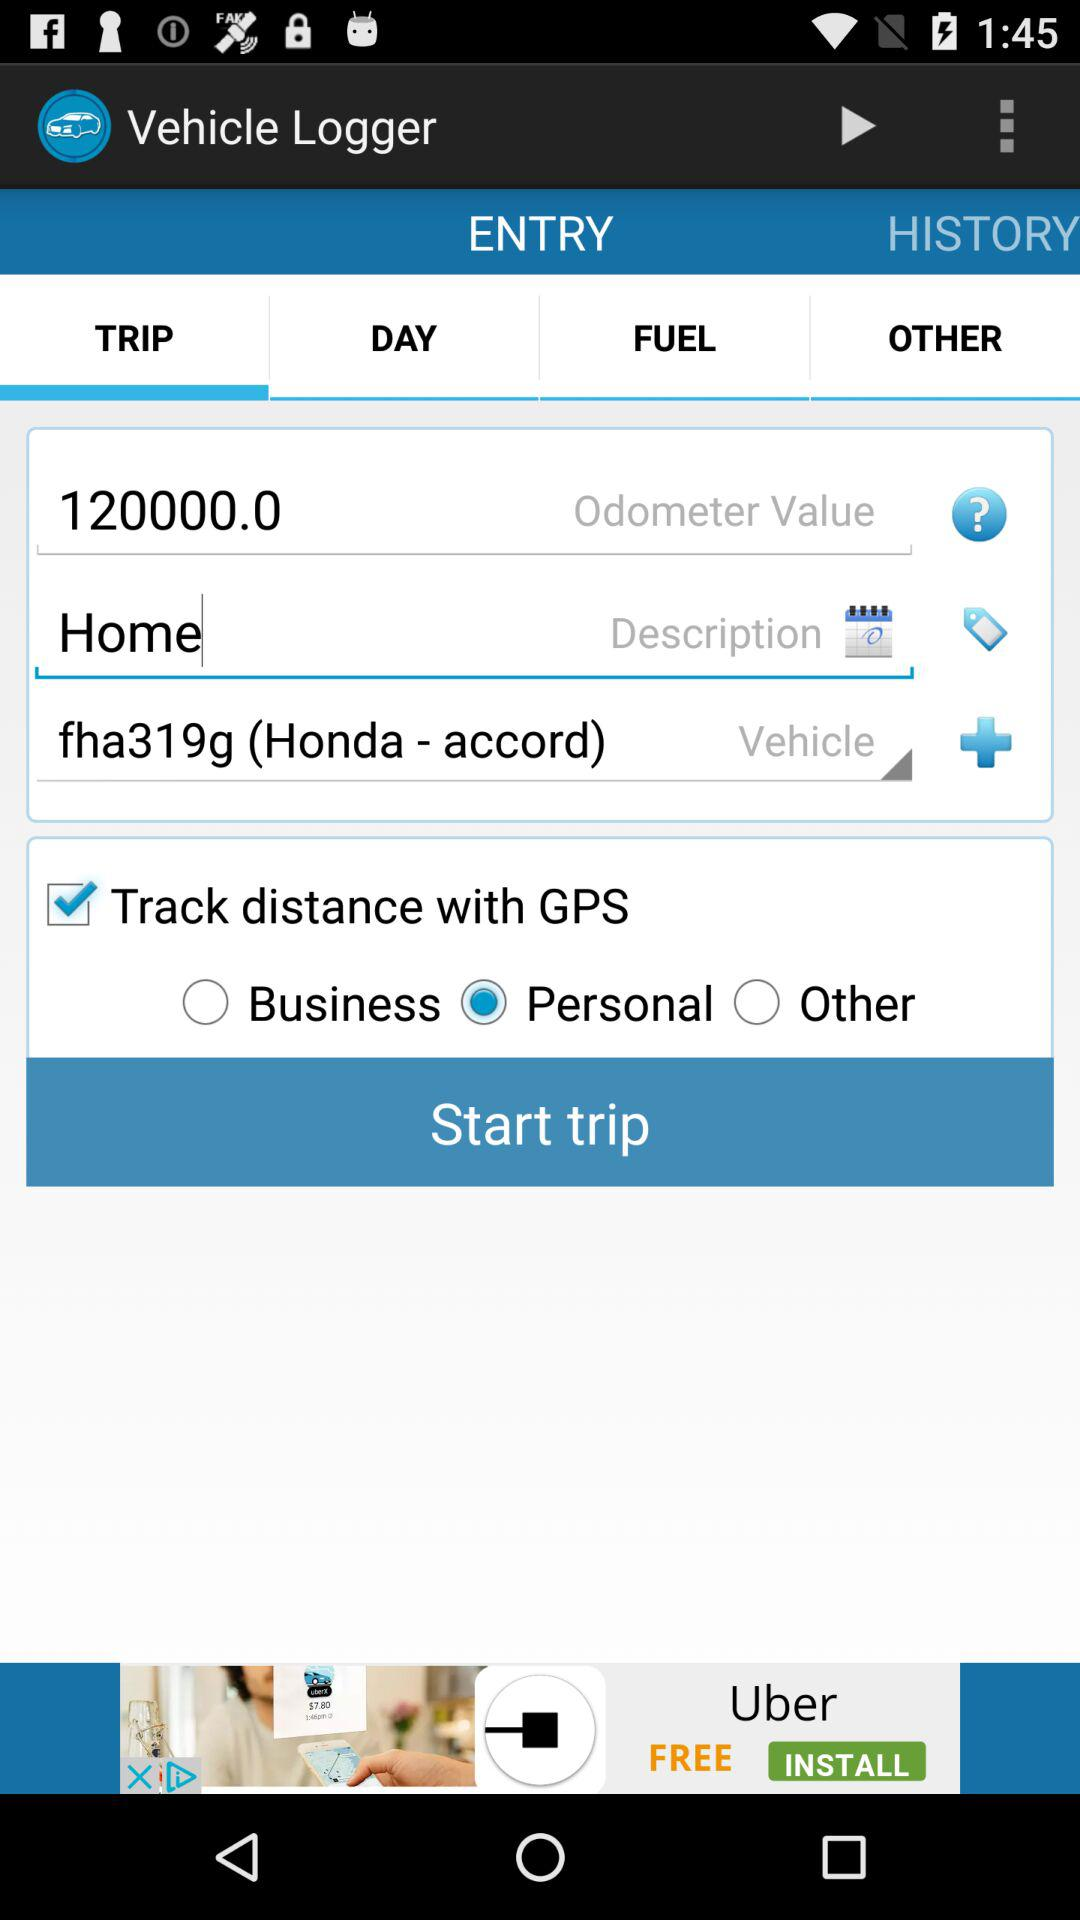What's entered in the description? The entered description is "Home". 